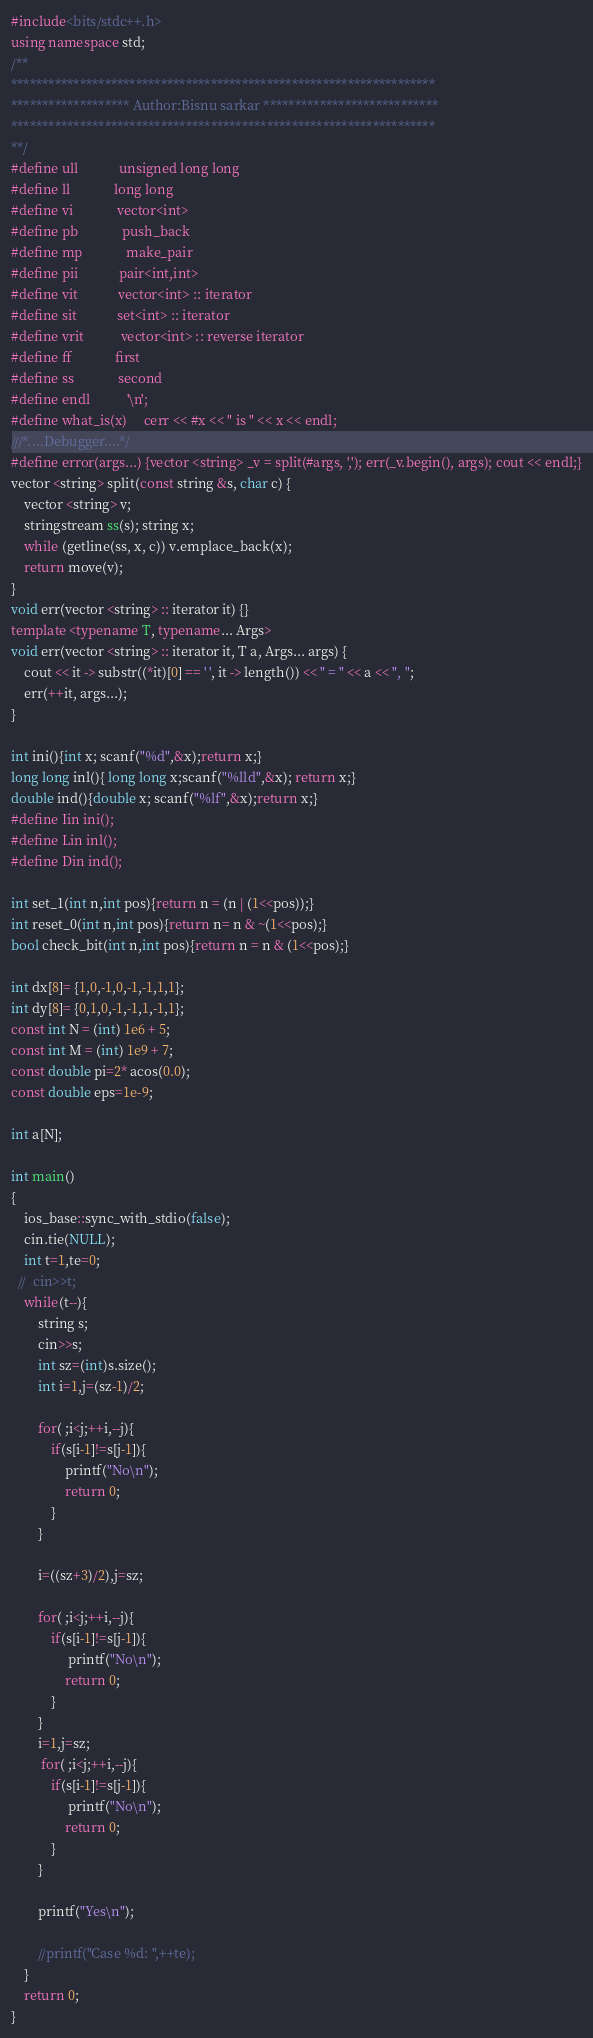Convert code to text. <code><loc_0><loc_0><loc_500><loc_500><_C++_>
#include<bits/stdc++.h>
using namespace std;
/**
********************************************************************
******************* Author:Bisnu sarkar ****************************
********************************************************************
**/
#define ull            unsigned long long
#define ll             long long
#define vi             vector<int>
#define pb             push_back
#define mp             make_pair
#define pii            pair<int,int>
#define vit            vector<int> :: iterator
#define sit            set<int> :: iterator
#define vrit           vector<int> :: reverse iterator
#define ff             first
#define ss             second
#define endl           '\n';
#define what_is(x)     cerr << #x << " is " << x << endl;
///*....Debugger....*/
#define error(args...) {vector <string> _v = split(#args, ','); err(_v.begin(), args); cout << endl;}
vector <string> split(const string &s, char c) {
    vector <string> v;
    stringstream ss(s); string x;
    while (getline(ss, x, c)) v.emplace_back(x);
    return move(v);
}
void err(vector <string> :: iterator it) {}
template <typename T, typename... Args>
void err(vector <string> :: iterator it, T a, Args... args) {
    cout << it -> substr((*it)[0] == ' ', it -> length()) << " = " << a << ", ";
    err(++it, args...);
}
 
int ini(){int x; scanf("%d",&x);return x;}
long long inl(){ long long x;scanf("%lld",&x); return x;}
double ind(){double x; scanf("%lf",&x);return x;}
#define Iin ini();
#define Lin inl();
#define Din ind();

int set_1(int n,int pos){return n = (n | (1<<pos));}
int reset_0(int n,int pos){return n= n & ~(1<<pos);}
bool check_bit(int n,int pos){return n = n & (1<<pos);}

int dx[8]= {1,0,-1,0,-1,-1,1,1};
int dy[8]= {0,1,0,-1,-1,1,-1,1};
const int N = (int) 1e6 + 5;
const int M = (int) 1e9 + 7;
const double pi=2* acos(0.0);
const double eps=1e-9;

int a[N];

int main()
{
    ios_base::sync_with_stdio(false); 
    cin.tie(NULL);  
    int t=1,te=0;
  //  cin>>t;
    while(t--){
        string s;
        cin>>s;
        int sz=(int)s.size();
        int i=1,j=(sz-1)/2;

        for( ;i<j;++i,--j){
            if(s[i-1]!=s[j-1]){
                printf("No\n");
                return 0;
            }
        }

        i=((sz+3)/2),j=sz;

        for( ;i<j;++i,--j){
            if(s[i-1]!=s[j-1]){
                 printf("No\n");
                return 0;
            }
        }
        i=1,j=sz;
         for( ;i<j;++i,--j){
            if(s[i-1]!=s[j-1]){
                 printf("No\n");
                return 0;
            }
        }

        printf("Yes\n");

        //printf("Case %d: ",++te);
    }
    return 0;
}


</code> 